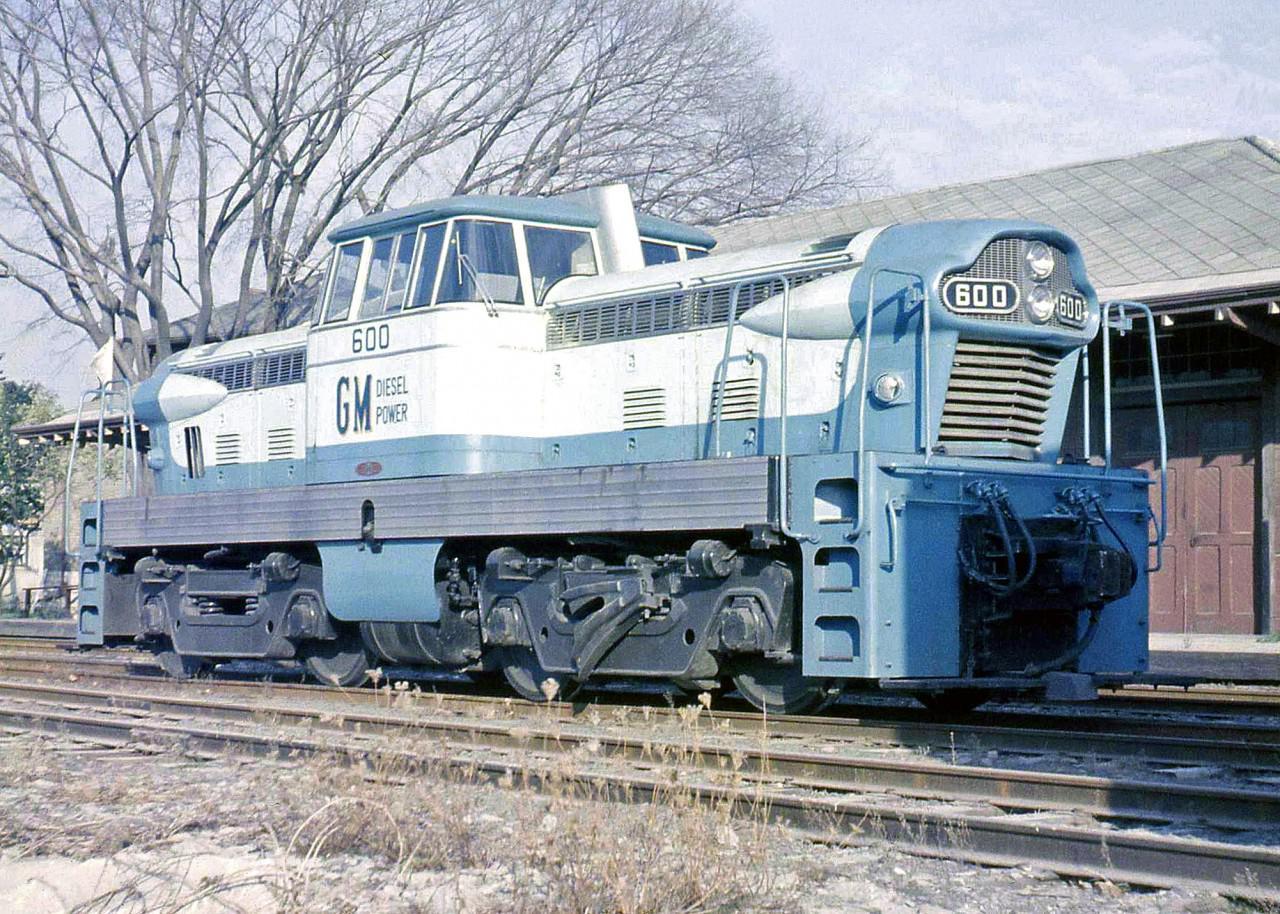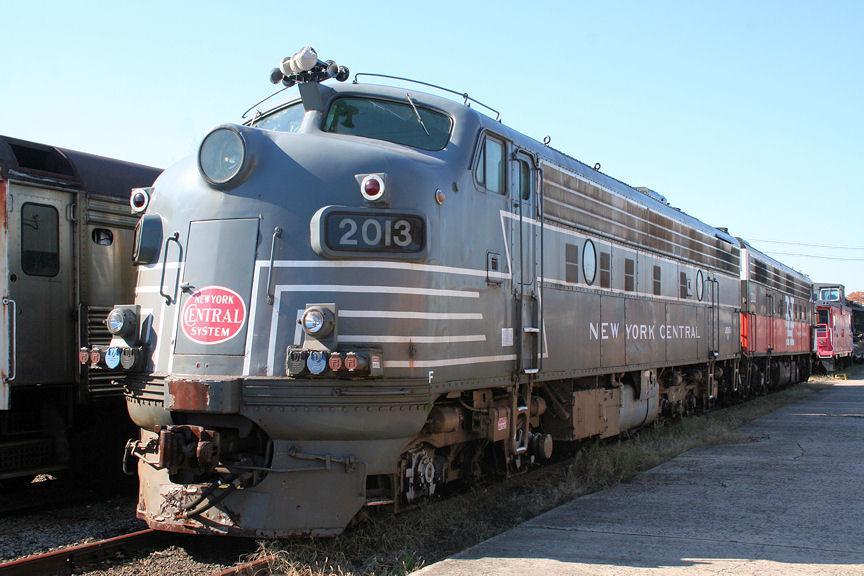The first image is the image on the left, the second image is the image on the right. Examine the images to the left and right. Is the description "One train is primarily white with at least one red stripe, and the other train is primarily red with a pale stripe." accurate? Answer yes or no. No. The first image is the image on the left, the second image is the image on the right. For the images displayed, is the sentence "The engine in the image on the right is white with a red stripe on it." factually correct? Answer yes or no. No. 